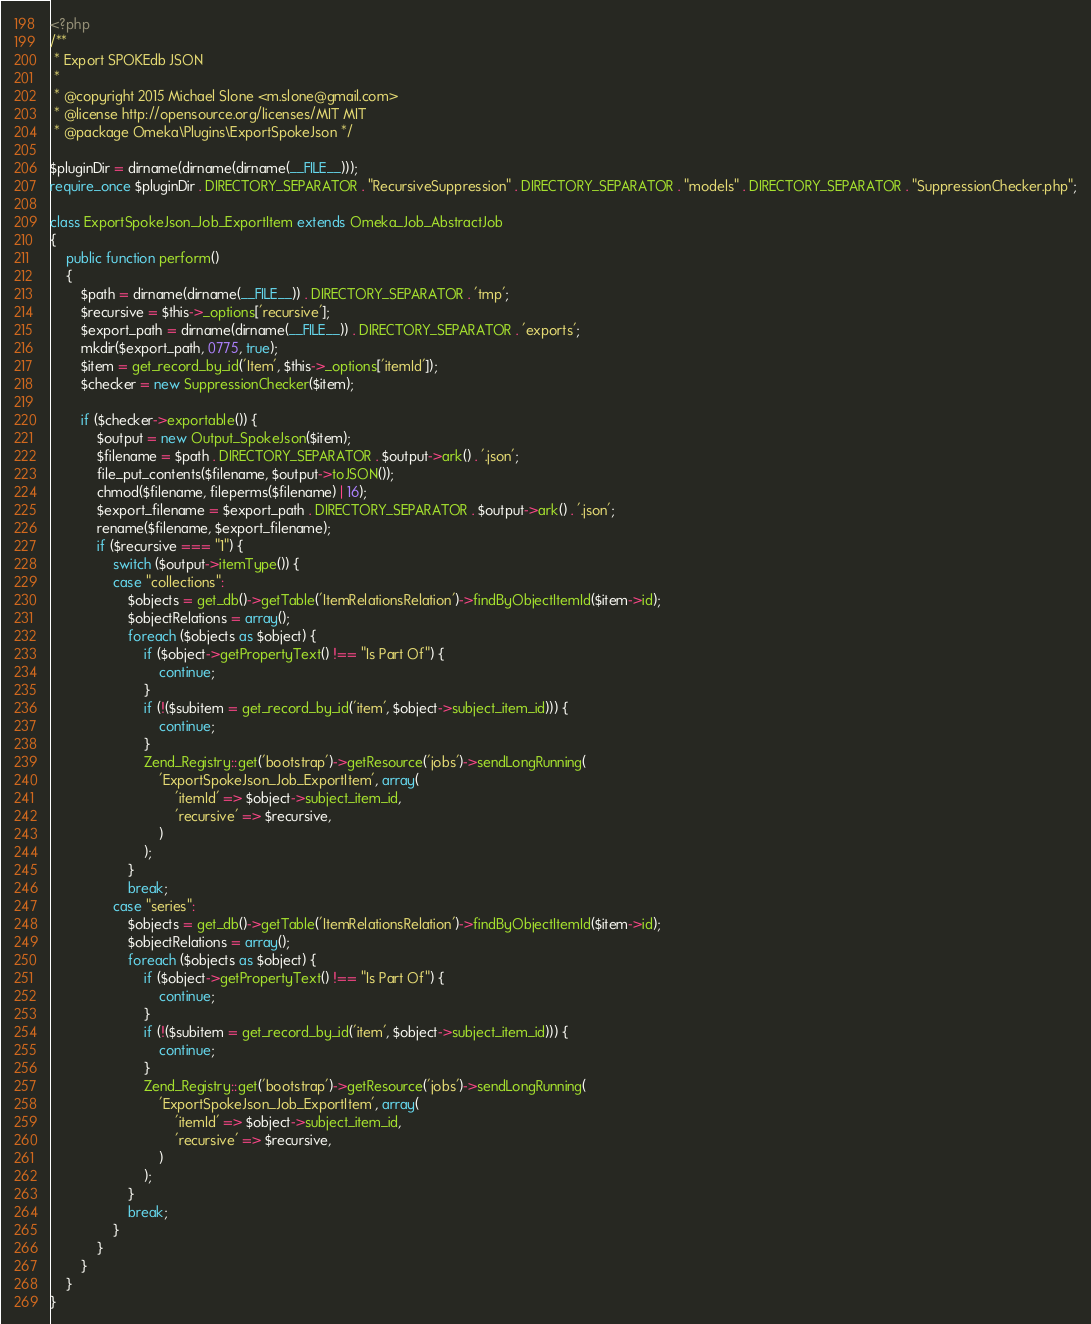<code> <loc_0><loc_0><loc_500><loc_500><_PHP_><?php
/**
 * Export SPOKEdb JSON
 *
 * @copyright 2015 Michael Slone <m.slone@gmail.com>
 * @license http://opensource.org/licenses/MIT MIT
 * @package Omeka\Plugins\ExportSpokeJson */

$pluginDir = dirname(dirname(dirname(__FILE__)));
require_once $pluginDir . DIRECTORY_SEPARATOR . "RecursiveSuppression" . DIRECTORY_SEPARATOR . "models" . DIRECTORY_SEPARATOR . "SuppressionChecker.php";

class ExportSpokeJson_Job_ExportItem extends Omeka_Job_AbstractJob
{
    public function perform()
    {
        $path = dirname(dirname(__FILE__)) . DIRECTORY_SEPARATOR . 'tmp';
        $recursive = $this->_options['recursive'];
        $export_path = dirname(dirname(__FILE__)) . DIRECTORY_SEPARATOR . 'exports';
        mkdir($export_path, 0775, true);
        $item = get_record_by_id('Item', $this->_options['itemId']);
        $checker = new SuppressionChecker($item);

        if ($checker->exportable()) {
            $output = new Output_SpokeJson($item);
            $filename = $path . DIRECTORY_SEPARATOR . $output->ark() . '.json';
            file_put_contents($filename, $output->toJSON());
            chmod($filename, fileperms($filename) | 16);
            $export_filename = $export_path . DIRECTORY_SEPARATOR . $output->ark() . '.json';
            rename($filename, $export_filename);
            if ($recursive === "1") {
                switch ($output->itemType()) {
                case "collections":
                    $objects = get_db()->getTable('ItemRelationsRelation')->findByObjectItemId($item->id);
                    $objectRelations = array();
                    foreach ($objects as $object) {
                        if ($object->getPropertyText() !== "Is Part Of") {
                            continue;
                        }
                        if (!($subitem = get_record_by_id('item', $object->subject_item_id))) {
                            continue;
                        }
                        Zend_Registry::get('bootstrap')->getResource('jobs')->sendLongRunning(
                            'ExportSpokeJson_Job_ExportItem', array(
                                'itemId' => $object->subject_item_id,
                                'recursive' => $recursive,
                            )
                        );
                    }
                    break;
                case "series":
                    $objects = get_db()->getTable('ItemRelationsRelation')->findByObjectItemId($item->id);
                    $objectRelations = array();
                    foreach ($objects as $object) {
                        if ($object->getPropertyText() !== "Is Part Of") {
                            continue;
                        }
                        if (!($subitem = get_record_by_id('item', $object->subject_item_id))) {
                            continue;
                        }
                        Zend_Registry::get('bootstrap')->getResource('jobs')->sendLongRunning(
                            'ExportSpokeJson_Job_ExportItem', array(
                                'itemId' => $object->subject_item_id,
                                'recursive' => $recursive,
                            )
                        );
                    }
                    break;
                }
            }
        }
    }
}
</code> 